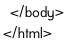<code> <loc_0><loc_0><loc_500><loc_500><_HTML_>  </body>
</html></code> 